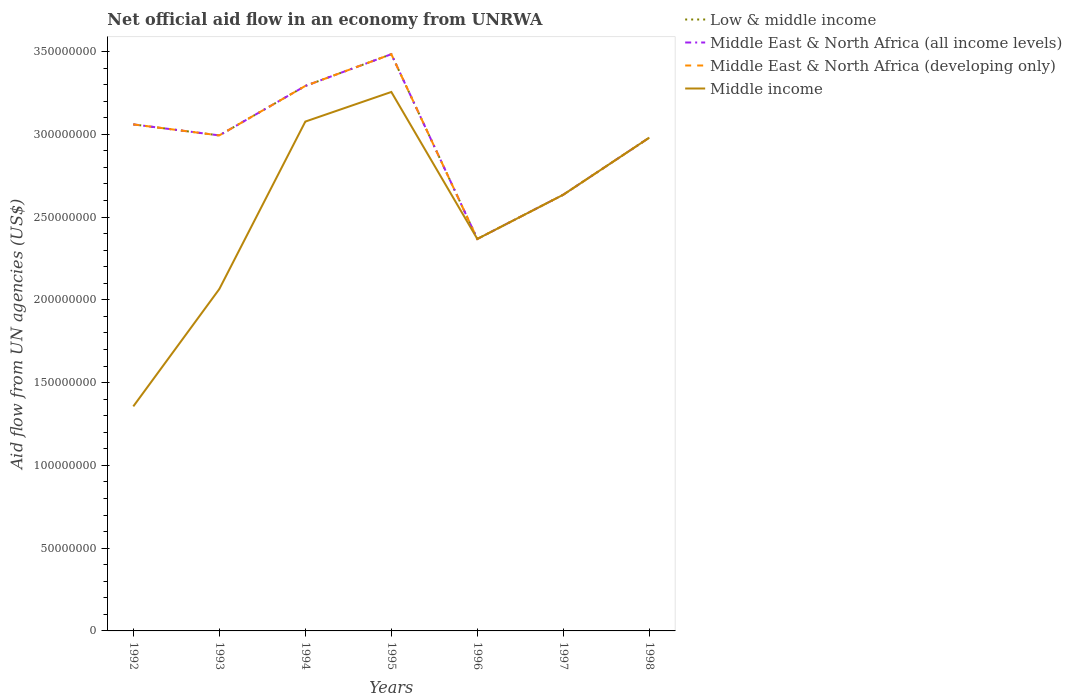How many different coloured lines are there?
Make the answer very short. 4. Is the number of lines equal to the number of legend labels?
Make the answer very short. Yes. Across all years, what is the maximum net official aid flow in Middle East & North Africa (developing only)?
Offer a very short reply. 2.37e+08. In which year was the net official aid flow in Middle East & North Africa (developing only) maximum?
Make the answer very short. 1996. What is the total net official aid flow in Middle East & North Africa (developing only) in the graph?
Make the answer very short. 1.33e+06. What is the difference between the highest and the second highest net official aid flow in Middle income?
Your answer should be compact. 1.90e+08. Is the net official aid flow in Low & middle income strictly greater than the net official aid flow in Middle East & North Africa (developing only) over the years?
Offer a very short reply. No. What is the difference between two consecutive major ticks on the Y-axis?
Make the answer very short. 5.00e+07. Are the values on the major ticks of Y-axis written in scientific E-notation?
Your answer should be compact. No. Does the graph contain grids?
Your answer should be very brief. No. How are the legend labels stacked?
Provide a short and direct response. Vertical. What is the title of the graph?
Make the answer very short. Net official aid flow in an economy from UNRWA. Does "Bosnia and Herzegovina" appear as one of the legend labels in the graph?
Your answer should be very brief. No. What is the label or title of the Y-axis?
Keep it short and to the point. Aid flow from UN agencies (US$). What is the Aid flow from UN agencies (US$) of Low & middle income in 1992?
Your answer should be compact. 3.06e+08. What is the Aid flow from UN agencies (US$) of Middle East & North Africa (all income levels) in 1992?
Your answer should be very brief. 3.06e+08. What is the Aid flow from UN agencies (US$) in Middle East & North Africa (developing only) in 1992?
Provide a succinct answer. 3.06e+08. What is the Aid flow from UN agencies (US$) of Middle income in 1992?
Give a very brief answer. 1.36e+08. What is the Aid flow from UN agencies (US$) in Low & middle income in 1993?
Your answer should be compact. 2.99e+08. What is the Aid flow from UN agencies (US$) in Middle East & North Africa (all income levels) in 1993?
Offer a terse response. 2.99e+08. What is the Aid flow from UN agencies (US$) in Middle East & North Africa (developing only) in 1993?
Ensure brevity in your answer.  2.99e+08. What is the Aid flow from UN agencies (US$) of Middle income in 1993?
Offer a terse response. 2.07e+08. What is the Aid flow from UN agencies (US$) of Low & middle income in 1994?
Your answer should be compact. 3.29e+08. What is the Aid flow from UN agencies (US$) in Middle East & North Africa (all income levels) in 1994?
Offer a terse response. 3.29e+08. What is the Aid flow from UN agencies (US$) in Middle East & North Africa (developing only) in 1994?
Make the answer very short. 3.29e+08. What is the Aid flow from UN agencies (US$) in Middle income in 1994?
Ensure brevity in your answer.  3.08e+08. What is the Aid flow from UN agencies (US$) of Low & middle income in 1995?
Provide a short and direct response. 3.48e+08. What is the Aid flow from UN agencies (US$) of Middle East & North Africa (all income levels) in 1995?
Offer a very short reply. 3.48e+08. What is the Aid flow from UN agencies (US$) of Middle East & North Africa (developing only) in 1995?
Offer a terse response. 3.48e+08. What is the Aid flow from UN agencies (US$) in Middle income in 1995?
Offer a terse response. 3.26e+08. What is the Aid flow from UN agencies (US$) of Low & middle income in 1996?
Your response must be concise. 2.37e+08. What is the Aid flow from UN agencies (US$) of Middle East & North Africa (all income levels) in 1996?
Keep it short and to the point. 2.37e+08. What is the Aid flow from UN agencies (US$) of Middle East & North Africa (developing only) in 1996?
Offer a very short reply. 2.37e+08. What is the Aid flow from UN agencies (US$) in Middle income in 1996?
Your answer should be very brief. 2.37e+08. What is the Aid flow from UN agencies (US$) of Low & middle income in 1997?
Your response must be concise. 2.64e+08. What is the Aid flow from UN agencies (US$) of Middle East & North Africa (all income levels) in 1997?
Offer a very short reply. 2.64e+08. What is the Aid flow from UN agencies (US$) in Middle East & North Africa (developing only) in 1997?
Ensure brevity in your answer.  2.64e+08. What is the Aid flow from UN agencies (US$) of Middle income in 1997?
Ensure brevity in your answer.  2.64e+08. What is the Aid flow from UN agencies (US$) in Low & middle income in 1998?
Your answer should be compact. 2.98e+08. What is the Aid flow from UN agencies (US$) in Middle East & North Africa (all income levels) in 1998?
Make the answer very short. 2.98e+08. What is the Aid flow from UN agencies (US$) of Middle East & North Africa (developing only) in 1998?
Give a very brief answer. 2.98e+08. What is the Aid flow from UN agencies (US$) in Middle income in 1998?
Your answer should be very brief. 2.98e+08. Across all years, what is the maximum Aid flow from UN agencies (US$) of Low & middle income?
Offer a very short reply. 3.48e+08. Across all years, what is the maximum Aid flow from UN agencies (US$) of Middle East & North Africa (all income levels)?
Provide a succinct answer. 3.48e+08. Across all years, what is the maximum Aid flow from UN agencies (US$) of Middle East & North Africa (developing only)?
Keep it short and to the point. 3.48e+08. Across all years, what is the maximum Aid flow from UN agencies (US$) in Middle income?
Offer a terse response. 3.26e+08. Across all years, what is the minimum Aid flow from UN agencies (US$) of Low & middle income?
Keep it short and to the point. 2.37e+08. Across all years, what is the minimum Aid flow from UN agencies (US$) in Middle East & North Africa (all income levels)?
Keep it short and to the point. 2.37e+08. Across all years, what is the minimum Aid flow from UN agencies (US$) of Middle East & North Africa (developing only)?
Your response must be concise. 2.37e+08. Across all years, what is the minimum Aid flow from UN agencies (US$) of Middle income?
Make the answer very short. 1.36e+08. What is the total Aid flow from UN agencies (US$) of Low & middle income in the graph?
Offer a very short reply. 2.08e+09. What is the total Aid flow from UN agencies (US$) in Middle East & North Africa (all income levels) in the graph?
Give a very brief answer. 2.08e+09. What is the total Aid flow from UN agencies (US$) in Middle East & North Africa (developing only) in the graph?
Keep it short and to the point. 2.08e+09. What is the total Aid flow from UN agencies (US$) in Middle income in the graph?
Provide a short and direct response. 1.77e+09. What is the difference between the Aid flow from UN agencies (US$) of Low & middle income in 1992 and that in 1993?
Provide a short and direct response. 6.65e+06. What is the difference between the Aid flow from UN agencies (US$) in Middle East & North Africa (all income levels) in 1992 and that in 1993?
Your response must be concise. 6.65e+06. What is the difference between the Aid flow from UN agencies (US$) in Middle East & North Africa (developing only) in 1992 and that in 1993?
Your answer should be very brief. 6.65e+06. What is the difference between the Aid flow from UN agencies (US$) of Middle income in 1992 and that in 1993?
Ensure brevity in your answer.  -7.09e+07. What is the difference between the Aid flow from UN agencies (US$) in Low & middle income in 1992 and that in 1994?
Make the answer very short. -2.32e+07. What is the difference between the Aid flow from UN agencies (US$) of Middle East & North Africa (all income levels) in 1992 and that in 1994?
Make the answer very short. -2.32e+07. What is the difference between the Aid flow from UN agencies (US$) of Middle East & North Africa (developing only) in 1992 and that in 1994?
Offer a terse response. -2.32e+07. What is the difference between the Aid flow from UN agencies (US$) in Middle income in 1992 and that in 1994?
Offer a very short reply. -1.72e+08. What is the difference between the Aid flow from UN agencies (US$) of Low & middle income in 1992 and that in 1995?
Make the answer very short. -4.24e+07. What is the difference between the Aid flow from UN agencies (US$) in Middle East & North Africa (all income levels) in 1992 and that in 1995?
Ensure brevity in your answer.  -4.24e+07. What is the difference between the Aid flow from UN agencies (US$) of Middle East & North Africa (developing only) in 1992 and that in 1995?
Offer a terse response. -4.24e+07. What is the difference between the Aid flow from UN agencies (US$) of Middle income in 1992 and that in 1995?
Provide a short and direct response. -1.90e+08. What is the difference between the Aid flow from UN agencies (US$) in Low & middle income in 1992 and that in 1996?
Ensure brevity in your answer.  6.92e+07. What is the difference between the Aid flow from UN agencies (US$) in Middle East & North Africa (all income levels) in 1992 and that in 1996?
Your response must be concise. 6.92e+07. What is the difference between the Aid flow from UN agencies (US$) of Middle East & North Africa (developing only) in 1992 and that in 1996?
Give a very brief answer. 6.92e+07. What is the difference between the Aid flow from UN agencies (US$) of Middle income in 1992 and that in 1996?
Ensure brevity in your answer.  -1.01e+08. What is the difference between the Aid flow from UN agencies (US$) in Low & middle income in 1992 and that in 1997?
Offer a very short reply. 4.25e+07. What is the difference between the Aid flow from UN agencies (US$) of Middle East & North Africa (all income levels) in 1992 and that in 1997?
Your answer should be very brief. 4.25e+07. What is the difference between the Aid flow from UN agencies (US$) in Middle East & North Africa (developing only) in 1992 and that in 1997?
Ensure brevity in your answer.  4.25e+07. What is the difference between the Aid flow from UN agencies (US$) in Middle income in 1992 and that in 1997?
Your answer should be very brief. -1.28e+08. What is the difference between the Aid flow from UN agencies (US$) in Low & middle income in 1992 and that in 1998?
Provide a succinct answer. 7.98e+06. What is the difference between the Aid flow from UN agencies (US$) in Middle East & North Africa (all income levels) in 1992 and that in 1998?
Keep it short and to the point. 7.98e+06. What is the difference between the Aid flow from UN agencies (US$) in Middle East & North Africa (developing only) in 1992 and that in 1998?
Ensure brevity in your answer.  7.98e+06. What is the difference between the Aid flow from UN agencies (US$) of Middle income in 1992 and that in 1998?
Your response must be concise. -1.62e+08. What is the difference between the Aid flow from UN agencies (US$) in Low & middle income in 1993 and that in 1994?
Keep it short and to the point. -2.99e+07. What is the difference between the Aid flow from UN agencies (US$) in Middle East & North Africa (all income levels) in 1993 and that in 1994?
Make the answer very short. -2.99e+07. What is the difference between the Aid flow from UN agencies (US$) in Middle East & North Africa (developing only) in 1993 and that in 1994?
Provide a short and direct response. -2.99e+07. What is the difference between the Aid flow from UN agencies (US$) in Middle income in 1993 and that in 1994?
Provide a succinct answer. -1.01e+08. What is the difference between the Aid flow from UN agencies (US$) in Low & middle income in 1993 and that in 1995?
Offer a terse response. -4.91e+07. What is the difference between the Aid flow from UN agencies (US$) in Middle East & North Africa (all income levels) in 1993 and that in 1995?
Keep it short and to the point. -4.91e+07. What is the difference between the Aid flow from UN agencies (US$) of Middle East & North Africa (developing only) in 1993 and that in 1995?
Make the answer very short. -4.91e+07. What is the difference between the Aid flow from UN agencies (US$) in Middle income in 1993 and that in 1995?
Make the answer very short. -1.19e+08. What is the difference between the Aid flow from UN agencies (US$) in Low & middle income in 1993 and that in 1996?
Ensure brevity in your answer.  6.26e+07. What is the difference between the Aid flow from UN agencies (US$) in Middle East & North Africa (all income levels) in 1993 and that in 1996?
Make the answer very short. 6.26e+07. What is the difference between the Aid flow from UN agencies (US$) of Middle East & North Africa (developing only) in 1993 and that in 1996?
Your answer should be very brief. 6.26e+07. What is the difference between the Aid flow from UN agencies (US$) of Middle income in 1993 and that in 1996?
Your response must be concise. -3.03e+07. What is the difference between the Aid flow from UN agencies (US$) of Low & middle income in 1993 and that in 1997?
Offer a very short reply. 3.58e+07. What is the difference between the Aid flow from UN agencies (US$) in Middle East & North Africa (all income levels) in 1993 and that in 1997?
Provide a succinct answer. 3.58e+07. What is the difference between the Aid flow from UN agencies (US$) in Middle East & North Africa (developing only) in 1993 and that in 1997?
Your answer should be compact. 3.58e+07. What is the difference between the Aid flow from UN agencies (US$) in Middle income in 1993 and that in 1997?
Offer a terse response. -5.70e+07. What is the difference between the Aid flow from UN agencies (US$) in Low & middle income in 1993 and that in 1998?
Your answer should be compact. 1.33e+06. What is the difference between the Aid flow from UN agencies (US$) in Middle East & North Africa (all income levels) in 1993 and that in 1998?
Your answer should be very brief. 1.33e+06. What is the difference between the Aid flow from UN agencies (US$) in Middle East & North Africa (developing only) in 1993 and that in 1998?
Offer a very short reply. 1.33e+06. What is the difference between the Aid flow from UN agencies (US$) of Middle income in 1993 and that in 1998?
Keep it short and to the point. -9.15e+07. What is the difference between the Aid flow from UN agencies (US$) in Low & middle income in 1994 and that in 1995?
Offer a terse response. -1.92e+07. What is the difference between the Aid flow from UN agencies (US$) in Middle East & North Africa (all income levels) in 1994 and that in 1995?
Make the answer very short. -1.92e+07. What is the difference between the Aid flow from UN agencies (US$) in Middle East & North Africa (developing only) in 1994 and that in 1995?
Ensure brevity in your answer.  -1.92e+07. What is the difference between the Aid flow from UN agencies (US$) of Middle income in 1994 and that in 1995?
Your answer should be compact. -1.79e+07. What is the difference between the Aid flow from UN agencies (US$) of Low & middle income in 1994 and that in 1996?
Offer a terse response. 9.24e+07. What is the difference between the Aid flow from UN agencies (US$) in Middle East & North Africa (all income levels) in 1994 and that in 1996?
Keep it short and to the point. 9.24e+07. What is the difference between the Aid flow from UN agencies (US$) of Middle East & North Africa (developing only) in 1994 and that in 1996?
Provide a succinct answer. 9.24e+07. What is the difference between the Aid flow from UN agencies (US$) in Middle income in 1994 and that in 1996?
Provide a succinct answer. 7.09e+07. What is the difference between the Aid flow from UN agencies (US$) in Low & middle income in 1994 and that in 1997?
Provide a short and direct response. 6.57e+07. What is the difference between the Aid flow from UN agencies (US$) of Middle East & North Africa (all income levels) in 1994 and that in 1997?
Provide a succinct answer. 6.57e+07. What is the difference between the Aid flow from UN agencies (US$) of Middle East & North Africa (developing only) in 1994 and that in 1997?
Provide a short and direct response. 6.57e+07. What is the difference between the Aid flow from UN agencies (US$) of Middle income in 1994 and that in 1997?
Your answer should be compact. 4.42e+07. What is the difference between the Aid flow from UN agencies (US$) of Low & middle income in 1994 and that in 1998?
Offer a terse response. 3.12e+07. What is the difference between the Aid flow from UN agencies (US$) of Middle East & North Africa (all income levels) in 1994 and that in 1998?
Your answer should be compact. 3.12e+07. What is the difference between the Aid flow from UN agencies (US$) in Middle East & North Africa (developing only) in 1994 and that in 1998?
Provide a succinct answer. 3.12e+07. What is the difference between the Aid flow from UN agencies (US$) of Middle income in 1994 and that in 1998?
Offer a terse response. 9.68e+06. What is the difference between the Aid flow from UN agencies (US$) in Low & middle income in 1995 and that in 1996?
Provide a short and direct response. 1.12e+08. What is the difference between the Aid flow from UN agencies (US$) of Middle East & North Africa (all income levels) in 1995 and that in 1996?
Give a very brief answer. 1.12e+08. What is the difference between the Aid flow from UN agencies (US$) of Middle East & North Africa (developing only) in 1995 and that in 1996?
Provide a short and direct response. 1.12e+08. What is the difference between the Aid flow from UN agencies (US$) in Middle income in 1995 and that in 1996?
Ensure brevity in your answer.  8.88e+07. What is the difference between the Aid flow from UN agencies (US$) in Low & middle income in 1995 and that in 1997?
Provide a short and direct response. 8.49e+07. What is the difference between the Aid flow from UN agencies (US$) in Middle East & North Africa (all income levels) in 1995 and that in 1997?
Provide a succinct answer. 8.49e+07. What is the difference between the Aid flow from UN agencies (US$) in Middle East & North Africa (developing only) in 1995 and that in 1997?
Ensure brevity in your answer.  8.49e+07. What is the difference between the Aid flow from UN agencies (US$) of Middle income in 1995 and that in 1997?
Your response must be concise. 6.20e+07. What is the difference between the Aid flow from UN agencies (US$) of Low & middle income in 1995 and that in 1998?
Your answer should be very brief. 5.04e+07. What is the difference between the Aid flow from UN agencies (US$) in Middle East & North Africa (all income levels) in 1995 and that in 1998?
Keep it short and to the point. 5.04e+07. What is the difference between the Aid flow from UN agencies (US$) in Middle East & North Africa (developing only) in 1995 and that in 1998?
Provide a succinct answer. 5.04e+07. What is the difference between the Aid flow from UN agencies (US$) in Middle income in 1995 and that in 1998?
Your answer should be compact. 2.76e+07. What is the difference between the Aid flow from UN agencies (US$) in Low & middle income in 1996 and that in 1997?
Ensure brevity in your answer.  -2.67e+07. What is the difference between the Aid flow from UN agencies (US$) of Middle East & North Africa (all income levels) in 1996 and that in 1997?
Keep it short and to the point. -2.67e+07. What is the difference between the Aid flow from UN agencies (US$) in Middle East & North Africa (developing only) in 1996 and that in 1997?
Your response must be concise. -2.67e+07. What is the difference between the Aid flow from UN agencies (US$) in Middle income in 1996 and that in 1997?
Offer a very short reply. -2.67e+07. What is the difference between the Aid flow from UN agencies (US$) in Low & middle income in 1996 and that in 1998?
Provide a short and direct response. -6.12e+07. What is the difference between the Aid flow from UN agencies (US$) in Middle East & North Africa (all income levels) in 1996 and that in 1998?
Your response must be concise. -6.12e+07. What is the difference between the Aid flow from UN agencies (US$) in Middle East & North Africa (developing only) in 1996 and that in 1998?
Offer a very short reply. -6.12e+07. What is the difference between the Aid flow from UN agencies (US$) in Middle income in 1996 and that in 1998?
Offer a very short reply. -6.12e+07. What is the difference between the Aid flow from UN agencies (US$) of Low & middle income in 1997 and that in 1998?
Offer a very short reply. -3.45e+07. What is the difference between the Aid flow from UN agencies (US$) of Middle East & North Africa (all income levels) in 1997 and that in 1998?
Offer a very short reply. -3.45e+07. What is the difference between the Aid flow from UN agencies (US$) in Middle East & North Africa (developing only) in 1997 and that in 1998?
Your answer should be compact. -3.45e+07. What is the difference between the Aid flow from UN agencies (US$) in Middle income in 1997 and that in 1998?
Offer a very short reply. -3.45e+07. What is the difference between the Aid flow from UN agencies (US$) in Low & middle income in 1992 and the Aid flow from UN agencies (US$) in Middle East & North Africa (all income levels) in 1993?
Your response must be concise. 6.65e+06. What is the difference between the Aid flow from UN agencies (US$) of Low & middle income in 1992 and the Aid flow from UN agencies (US$) of Middle East & North Africa (developing only) in 1993?
Your answer should be compact. 6.65e+06. What is the difference between the Aid flow from UN agencies (US$) in Low & middle income in 1992 and the Aid flow from UN agencies (US$) in Middle income in 1993?
Your response must be concise. 9.95e+07. What is the difference between the Aid flow from UN agencies (US$) in Middle East & North Africa (all income levels) in 1992 and the Aid flow from UN agencies (US$) in Middle East & North Africa (developing only) in 1993?
Your answer should be compact. 6.65e+06. What is the difference between the Aid flow from UN agencies (US$) of Middle East & North Africa (all income levels) in 1992 and the Aid flow from UN agencies (US$) of Middle income in 1993?
Make the answer very short. 9.95e+07. What is the difference between the Aid flow from UN agencies (US$) of Middle East & North Africa (developing only) in 1992 and the Aid flow from UN agencies (US$) of Middle income in 1993?
Provide a short and direct response. 9.95e+07. What is the difference between the Aid flow from UN agencies (US$) of Low & middle income in 1992 and the Aid flow from UN agencies (US$) of Middle East & North Africa (all income levels) in 1994?
Give a very brief answer. -2.32e+07. What is the difference between the Aid flow from UN agencies (US$) in Low & middle income in 1992 and the Aid flow from UN agencies (US$) in Middle East & North Africa (developing only) in 1994?
Your answer should be compact. -2.32e+07. What is the difference between the Aid flow from UN agencies (US$) in Low & middle income in 1992 and the Aid flow from UN agencies (US$) in Middle income in 1994?
Offer a very short reply. -1.70e+06. What is the difference between the Aid flow from UN agencies (US$) in Middle East & North Africa (all income levels) in 1992 and the Aid flow from UN agencies (US$) in Middle East & North Africa (developing only) in 1994?
Provide a succinct answer. -2.32e+07. What is the difference between the Aid flow from UN agencies (US$) in Middle East & North Africa (all income levels) in 1992 and the Aid flow from UN agencies (US$) in Middle income in 1994?
Give a very brief answer. -1.70e+06. What is the difference between the Aid flow from UN agencies (US$) of Middle East & North Africa (developing only) in 1992 and the Aid flow from UN agencies (US$) of Middle income in 1994?
Your answer should be very brief. -1.70e+06. What is the difference between the Aid flow from UN agencies (US$) in Low & middle income in 1992 and the Aid flow from UN agencies (US$) in Middle East & North Africa (all income levels) in 1995?
Your answer should be very brief. -4.24e+07. What is the difference between the Aid flow from UN agencies (US$) in Low & middle income in 1992 and the Aid flow from UN agencies (US$) in Middle East & North Africa (developing only) in 1995?
Keep it short and to the point. -4.24e+07. What is the difference between the Aid flow from UN agencies (US$) of Low & middle income in 1992 and the Aid flow from UN agencies (US$) of Middle income in 1995?
Provide a short and direct response. -1.96e+07. What is the difference between the Aid flow from UN agencies (US$) of Middle East & North Africa (all income levels) in 1992 and the Aid flow from UN agencies (US$) of Middle East & North Africa (developing only) in 1995?
Offer a very short reply. -4.24e+07. What is the difference between the Aid flow from UN agencies (US$) in Middle East & North Africa (all income levels) in 1992 and the Aid flow from UN agencies (US$) in Middle income in 1995?
Keep it short and to the point. -1.96e+07. What is the difference between the Aid flow from UN agencies (US$) in Middle East & North Africa (developing only) in 1992 and the Aid flow from UN agencies (US$) in Middle income in 1995?
Your response must be concise. -1.96e+07. What is the difference between the Aid flow from UN agencies (US$) of Low & middle income in 1992 and the Aid flow from UN agencies (US$) of Middle East & North Africa (all income levels) in 1996?
Ensure brevity in your answer.  6.92e+07. What is the difference between the Aid flow from UN agencies (US$) in Low & middle income in 1992 and the Aid flow from UN agencies (US$) in Middle East & North Africa (developing only) in 1996?
Offer a very short reply. 6.92e+07. What is the difference between the Aid flow from UN agencies (US$) in Low & middle income in 1992 and the Aid flow from UN agencies (US$) in Middle income in 1996?
Provide a short and direct response. 6.92e+07. What is the difference between the Aid flow from UN agencies (US$) in Middle East & North Africa (all income levels) in 1992 and the Aid flow from UN agencies (US$) in Middle East & North Africa (developing only) in 1996?
Offer a terse response. 6.92e+07. What is the difference between the Aid flow from UN agencies (US$) of Middle East & North Africa (all income levels) in 1992 and the Aid flow from UN agencies (US$) of Middle income in 1996?
Your answer should be compact. 6.92e+07. What is the difference between the Aid flow from UN agencies (US$) in Middle East & North Africa (developing only) in 1992 and the Aid flow from UN agencies (US$) in Middle income in 1996?
Offer a terse response. 6.92e+07. What is the difference between the Aid flow from UN agencies (US$) of Low & middle income in 1992 and the Aid flow from UN agencies (US$) of Middle East & North Africa (all income levels) in 1997?
Offer a very short reply. 4.25e+07. What is the difference between the Aid flow from UN agencies (US$) of Low & middle income in 1992 and the Aid flow from UN agencies (US$) of Middle East & North Africa (developing only) in 1997?
Offer a very short reply. 4.25e+07. What is the difference between the Aid flow from UN agencies (US$) in Low & middle income in 1992 and the Aid flow from UN agencies (US$) in Middle income in 1997?
Offer a terse response. 4.25e+07. What is the difference between the Aid flow from UN agencies (US$) in Middle East & North Africa (all income levels) in 1992 and the Aid flow from UN agencies (US$) in Middle East & North Africa (developing only) in 1997?
Give a very brief answer. 4.25e+07. What is the difference between the Aid flow from UN agencies (US$) in Middle East & North Africa (all income levels) in 1992 and the Aid flow from UN agencies (US$) in Middle income in 1997?
Provide a succinct answer. 4.25e+07. What is the difference between the Aid flow from UN agencies (US$) in Middle East & North Africa (developing only) in 1992 and the Aid flow from UN agencies (US$) in Middle income in 1997?
Offer a very short reply. 4.25e+07. What is the difference between the Aid flow from UN agencies (US$) in Low & middle income in 1992 and the Aid flow from UN agencies (US$) in Middle East & North Africa (all income levels) in 1998?
Provide a short and direct response. 7.98e+06. What is the difference between the Aid flow from UN agencies (US$) of Low & middle income in 1992 and the Aid flow from UN agencies (US$) of Middle East & North Africa (developing only) in 1998?
Your answer should be very brief. 7.98e+06. What is the difference between the Aid flow from UN agencies (US$) in Low & middle income in 1992 and the Aid flow from UN agencies (US$) in Middle income in 1998?
Provide a short and direct response. 7.98e+06. What is the difference between the Aid flow from UN agencies (US$) of Middle East & North Africa (all income levels) in 1992 and the Aid flow from UN agencies (US$) of Middle East & North Africa (developing only) in 1998?
Your answer should be very brief. 7.98e+06. What is the difference between the Aid flow from UN agencies (US$) in Middle East & North Africa (all income levels) in 1992 and the Aid flow from UN agencies (US$) in Middle income in 1998?
Ensure brevity in your answer.  7.98e+06. What is the difference between the Aid flow from UN agencies (US$) in Middle East & North Africa (developing only) in 1992 and the Aid flow from UN agencies (US$) in Middle income in 1998?
Keep it short and to the point. 7.98e+06. What is the difference between the Aid flow from UN agencies (US$) in Low & middle income in 1993 and the Aid flow from UN agencies (US$) in Middle East & North Africa (all income levels) in 1994?
Make the answer very short. -2.99e+07. What is the difference between the Aid flow from UN agencies (US$) of Low & middle income in 1993 and the Aid flow from UN agencies (US$) of Middle East & North Africa (developing only) in 1994?
Keep it short and to the point. -2.99e+07. What is the difference between the Aid flow from UN agencies (US$) in Low & middle income in 1993 and the Aid flow from UN agencies (US$) in Middle income in 1994?
Give a very brief answer. -8.35e+06. What is the difference between the Aid flow from UN agencies (US$) of Middle East & North Africa (all income levels) in 1993 and the Aid flow from UN agencies (US$) of Middle East & North Africa (developing only) in 1994?
Your answer should be very brief. -2.99e+07. What is the difference between the Aid flow from UN agencies (US$) in Middle East & North Africa (all income levels) in 1993 and the Aid flow from UN agencies (US$) in Middle income in 1994?
Your response must be concise. -8.35e+06. What is the difference between the Aid flow from UN agencies (US$) of Middle East & North Africa (developing only) in 1993 and the Aid flow from UN agencies (US$) of Middle income in 1994?
Keep it short and to the point. -8.35e+06. What is the difference between the Aid flow from UN agencies (US$) in Low & middle income in 1993 and the Aid flow from UN agencies (US$) in Middle East & North Africa (all income levels) in 1995?
Keep it short and to the point. -4.91e+07. What is the difference between the Aid flow from UN agencies (US$) in Low & middle income in 1993 and the Aid flow from UN agencies (US$) in Middle East & North Africa (developing only) in 1995?
Provide a succinct answer. -4.91e+07. What is the difference between the Aid flow from UN agencies (US$) of Low & middle income in 1993 and the Aid flow from UN agencies (US$) of Middle income in 1995?
Your answer should be very brief. -2.62e+07. What is the difference between the Aid flow from UN agencies (US$) of Middle East & North Africa (all income levels) in 1993 and the Aid flow from UN agencies (US$) of Middle East & North Africa (developing only) in 1995?
Provide a short and direct response. -4.91e+07. What is the difference between the Aid flow from UN agencies (US$) of Middle East & North Africa (all income levels) in 1993 and the Aid flow from UN agencies (US$) of Middle income in 1995?
Offer a very short reply. -2.62e+07. What is the difference between the Aid flow from UN agencies (US$) of Middle East & North Africa (developing only) in 1993 and the Aid flow from UN agencies (US$) of Middle income in 1995?
Offer a terse response. -2.62e+07. What is the difference between the Aid flow from UN agencies (US$) in Low & middle income in 1993 and the Aid flow from UN agencies (US$) in Middle East & North Africa (all income levels) in 1996?
Your response must be concise. 6.26e+07. What is the difference between the Aid flow from UN agencies (US$) of Low & middle income in 1993 and the Aid flow from UN agencies (US$) of Middle East & North Africa (developing only) in 1996?
Your response must be concise. 6.26e+07. What is the difference between the Aid flow from UN agencies (US$) of Low & middle income in 1993 and the Aid flow from UN agencies (US$) of Middle income in 1996?
Offer a terse response. 6.26e+07. What is the difference between the Aid flow from UN agencies (US$) in Middle East & North Africa (all income levels) in 1993 and the Aid flow from UN agencies (US$) in Middle East & North Africa (developing only) in 1996?
Offer a very short reply. 6.26e+07. What is the difference between the Aid flow from UN agencies (US$) of Middle East & North Africa (all income levels) in 1993 and the Aid flow from UN agencies (US$) of Middle income in 1996?
Your answer should be very brief. 6.26e+07. What is the difference between the Aid flow from UN agencies (US$) of Middle East & North Africa (developing only) in 1993 and the Aid flow from UN agencies (US$) of Middle income in 1996?
Your answer should be very brief. 6.26e+07. What is the difference between the Aid flow from UN agencies (US$) in Low & middle income in 1993 and the Aid flow from UN agencies (US$) in Middle East & North Africa (all income levels) in 1997?
Your response must be concise. 3.58e+07. What is the difference between the Aid flow from UN agencies (US$) of Low & middle income in 1993 and the Aid flow from UN agencies (US$) of Middle East & North Africa (developing only) in 1997?
Ensure brevity in your answer.  3.58e+07. What is the difference between the Aid flow from UN agencies (US$) in Low & middle income in 1993 and the Aid flow from UN agencies (US$) in Middle income in 1997?
Offer a terse response. 3.58e+07. What is the difference between the Aid flow from UN agencies (US$) in Middle East & North Africa (all income levels) in 1993 and the Aid flow from UN agencies (US$) in Middle East & North Africa (developing only) in 1997?
Ensure brevity in your answer.  3.58e+07. What is the difference between the Aid flow from UN agencies (US$) in Middle East & North Africa (all income levels) in 1993 and the Aid flow from UN agencies (US$) in Middle income in 1997?
Offer a very short reply. 3.58e+07. What is the difference between the Aid flow from UN agencies (US$) of Middle East & North Africa (developing only) in 1993 and the Aid flow from UN agencies (US$) of Middle income in 1997?
Keep it short and to the point. 3.58e+07. What is the difference between the Aid flow from UN agencies (US$) in Low & middle income in 1993 and the Aid flow from UN agencies (US$) in Middle East & North Africa (all income levels) in 1998?
Your answer should be compact. 1.33e+06. What is the difference between the Aid flow from UN agencies (US$) in Low & middle income in 1993 and the Aid flow from UN agencies (US$) in Middle East & North Africa (developing only) in 1998?
Provide a short and direct response. 1.33e+06. What is the difference between the Aid flow from UN agencies (US$) in Low & middle income in 1993 and the Aid flow from UN agencies (US$) in Middle income in 1998?
Your answer should be compact. 1.33e+06. What is the difference between the Aid flow from UN agencies (US$) of Middle East & North Africa (all income levels) in 1993 and the Aid flow from UN agencies (US$) of Middle East & North Africa (developing only) in 1998?
Your answer should be very brief. 1.33e+06. What is the difference between the Aid flow from UN agencies (US$) of Middle East & North Africa (all income levels) in 1993 and the Aid flow from UN agencies (US$) of Middle income in 1998?
Provide a succinct answer. 1.33e+06. What is the difference between the Aid flow from UN agencies (US$) of Middle East & North Africa (developing only) in 1993 and the Aid flow from UN agencies (US$) of Middle income in 1998?
Your answer should be very brief. 1.33e+06. What is the difference between the Aid flow from UN agencies (US$) in Low & middle income in 1994 and the Aid flow from UN agencies (US$) in Middle East & North Africa (all income levels) in 1995?
Keep it short and to the point. -1.92e+07. What is the difference between the Aid flow from UN agencies (US$) in Low & middle income in 1994 and the Aid flow from UN agencies (US$) in Middle East & North Africa (developing only) in 1995?
Give a very brief answer. -1.92e+07. What is the difference between the Aid flow from UN agencies (US$) in Low & middle income in 1994 and the Aid flow from UN agencies (US$) in Middle income in 1995?
Give a very brief answer. 3.64e+06. What is the difference between the Aid flow from UN agencies (US$) of Middle East & North Africa (all income levels) in 1994 and the Aid flow from UN agencies (US$) of Middle East & North Africa (developing only) in 1995?
Offer a terse response. -1.92e+07. What is the difference between the Aid flow from UN agencies (US$) in Middle East & North Africa (all income levels) in 1994 and the Aid flow from UN agencies (US$) in Middle income in 1995?
Your answer should be compact. 3.64e+06. What is the difference between the Aid flow from UN agencies (US$) in Middle East & North Africa (developing only) in 1994 and the Aid flow from UN agencies (US$) in Middle income in 1995?
Your response must be concise. 3.64e+06. What is the difference between the Aid flow from UN agencies (US$) in Low & middle income in 1994 and the Aid flow from UN agencies (US$) in Middle East & North Africa (all income levels) in 1996?
Provide a succinct answer. 9.24e+07. What is the difference between the Aid flow from UN agencies (US$) in Low & middle income in 1994 and the Aid flow from UN agencies (US$) in Middle East & North Africa (developing only) in 1996?
Give a very brief answer. 9.24e+07. What is the difference between the Aid flow from UN agencies (US$) of Low & middle income in 1994 and the Aid flow from UN agencies (US$) of Middle income in 1996?
Your answer should be very brief. 9.24e+07. What is the difference between the Aid flow from UN agencies (US$) of Middle East & North Africa (all income levels) in 1994 and the Aid flow from UN agencies (US$) of Middle East & North Africa (developing only) in 1996?
Your response must be concise. 9.24e+07. What is the difference between the Aid flow from UN agencies (US$) in Middle East & North Africa (all income levels) in 1994 and the Aid flow from UN agencies (US$) in Middle income in 1996?
Ensure brevity in your answer.  9.24e+07. What is the difference between the Aid flow from UN agencies (US$) in Middle East & North Africa (developing only) in 1994 and the Aid flow from UN agencies (US$) in Middle income in 1996?
Keep it short and to the point. 9.24e+07. What is the difference between the Aid flow from UN agencies (US$) in Low & middle income in 1994 and the Aid flow from UN agencies (US$) in Middle East & North Africa (all income levels) in 1997?
Offer a terse response. 6.57e+07. What is the difference between the Aid flow from UN agencies (US$) in Low & middle income in 1994 and the Aid flow from UN agencies (US$) in Middle East & North Africa (developing only) in 1997?
Your response must be concise. 6.57e+07. What is the difference between the Aid flow from UN agencies (US$) of Low & middle income in 1994 and the Aid flow from UN agencies (US$) of Middle income in 1997?
Make the answer very short. 6.57e+07. What is the difference between the Aid flow from UN agencies (US$) in Middle East & North Africa (all income levels) in 1994 and the Aid flow from UN agencies (US$) in Middle East & North Africa (developing only) in 1997?
Ensure brevity in your answer.  6.57e+07. What is the difference between the Aid flow from UN agencies (US$) in Middle East & North Africa (all income levels) in 1994 and the Aid flow from UN agencies (US$) in Middle income in 1997?
Provide a succinct answer. 6.57e+07. What is the difference between the Aid flow from UN agencies (US$) of Middle East & North Africa (developing only) in 1994 and the Aid flow from UN agencies (US$) of Middle income in 1997?
Offer a very short reply. 6.57e+07. What is the difference between the Aid flow from UN agencies (US$) of Low & middle income in 1994 and the Aid flow from UN agencies (US$) of Middle East & North Africa (all income levels) in 1998?
Provide a short and direct response. 3.12e+07. What is the difference between the Aid flow from UN agencies (US$) of Low & middle income in 1994 and the Aid flow from UN agencies (US$) of Middle East & North Africa (developing only) in 1998?
Give a very brief answer. 3.12e+07. What is the difference between the Aid flow from UN agencies (US$) of Low & middle income in 1994 and the Aid flow from UN agencies (US$) of Middle income in 1998?
Provide a succinct answer. 3.12e+07. What is the difference between the Aid flow from UN agencies (US$) in Middle East & North Africa (all income levels) in 1994 and the Aid flow from UN agencies (US$) in Middle East & North Africa (developing only) in 1998?
Your answer should be very brief. 3.12e+07. What is the difference between the Aid flow from UN agencies (US$) of Middle East & North Africa (all income levels) in 1994 and the Aid flow from UN agencies (US$) of Middle income in 1998?
Provide a short and direct response. 3.12e+07. What is the difference between the Aid flow from UN agencies (US$) in Middle East & North Africa (developing only) in 1994 and the Aid flow from UN agencies (US$) in Middle income in 1998?
Your response must be concise. 3.12e+07. What is the difference between the Aid flow from UN agencies (US$) of Low & middle income in 1995 and the Aid flow from UN agencies (US$) of Middle East & North Africa (all income levels) in 1996?
Your response must be concise. 1.12e+08. What is the difference between the Aid flow from UN agencies (US$) of Low & middle income in 1995 and the Aid flow from UN agencies (US$) of Middle East & North Africa (developing only) in 1996?
Make the answer very short. 1.12e+08. What is the difference between the Aid flow from UN agencies (US$) of Low & middle income in 1995 and the Aid flow from UN agencies (US$) of Middle income in 1996?
Give a very brief answer. 1.12e+08. What is the difference between the Aid flow from UN agencies (US$) of Middle East & North Africa (all income levels) in 1995 and the Aid flow from UN agencies (US$) of Middle East & North Africa (developing only) in 1996?
Ensure brevity in your answer.  1.12e+08. What is the difference between the Aid flow from UN agencies (US$) in Middle East & North Africa (all income levels) in 1995 and the Aid flow from UN agencies (US$) in Middle income in 1996?
Make the answer very short. 1.12e+08. What is the difference between the Aid flow from UN agencies (US$) in Middle East & North Africa (developing only) in 1995 and the Aid flow from UN agencies (US$) in Middle income in 1996?
Your answer should be compact. 1.12e+08. What is the difference between the Aid flow from UN agencies (US$) in Low & middle income in 1995 and the Aid flow from UN agencies (US$) in Middle East & North Africa (all income levels) in 1997?
Your response must be concise. 8.49e+07. What is the difference between the Aid flow from UN agencies (US$) of Low & middle income in 1995 and the Aid flow from UN agencies (US$) of Middle East & North Africa (developing only) in 1997?
Offer a very short reply. 8.49e+07. What is the difference between the Aid flow from UN agencies (US$) of Low & middle income in 1995 and the Aid flow from UN agencies (US$) of Middle income in 1997?
Your answer should be compact. 8.49e+07. What is the difference between the Aid flow from UN agencies (US$) of Middle East & North Africa (all income levels) in 1995 and the Aid flow from UN agencies (US$) of Middle East & North Africa (developing only) in 1997?
Keep it short and to the point. 8.49e+07. What is the difference between the Aid flow from UN agencies (US$) of Middle East & North Africa (all income levels) in 1995 and the Aid flow from UN agencies (US$) of Middle income in 1997?
Offer a terse response. 8.49e+07. What is the difference between the Aid flow from UN agencies (US$) of Middle East & North Africa (developing only) in 1995 and the Aid flow from UN agencies (US$) of Middle income in 1997?
Ensure brevity in your answer.  8.49e+07. What is the difference between the Aid flow from UN agencies (US$) in Low & middle income in 1995 and the Aid flow from UN agencies (US$) in Middle East & North Africa (all income levels) in 1998?
Your answer should be compact. 5.04e+07. What is the difference between the Aid flow from UN agencies (US$) of Low & middle income in 1995 and the Aid flow from UN agencies (US$) of Middle East & North Africa (developing only) in 1998?
Your answer should be very brief. 5.04e+07. What is the difference between the Aid flow from UN agencies (US$) in Low & middle income in 1995 and the Aid flow from UN agencies (US$) in Middle income in 1998?
Offer a terse response. 5.04e+07. What is the difference between the Aid flow from UN agencies (US$) in Middle East & North Africa (all income levels) in 1995 and the Aid flow from UN agencies (US$) in Middle East & North Africa (developing only) in 1998?
Provide a short and direct response. 5.04e+07. What is the difference between the Aid flow from UN agencies (US$) in Middle East & North Africa (all income levels) in 1995 and the Aid flow from UN agencies (US$) in Middle income in 1998?
Provide a short and direct response. 5.04e+07. What is the difference between the Aid flow from UN agencies (US$) in Middle East & North Africa (developing only) in 1995 and the Aid flow from UN agencies (US$) in Middle income in 1998?
Your answer should be compact. 5.04e+07. What is the difference between the Aid flow from UN agencies (US$) of Low & middle income in 1996 and the Aid flow from UN agencies (US$) of Middle East & North Africa (all income levels) in 1997?
Offer a terse response. -2.67e+07. What is the difference between the Aid flow from UN agencies (US$) in Low & middle income in 1996 and the Aid flow from UN agencies (US$) in Middle East & North Africa (developing only) in 1997?
Offer a terse response. -2.67e+07. What is the difference between the Aid flow from UN agencies (US$) in Low & middle income in 1996 and the Aid flow from UN agencies (US$) in Middle income in 1997?
Provide a succinct answer. -2.67e+07. What is the difference between the Aid flow from UN agencies (US$) of Middle East & North Africa (all income levels) in 1996 and the Aid flow from UN agencies (US$) of Middle East & North Africa (developing only) in 1997?
Your answer should be very brief. -2.67e+07. What is the difference between the Aid flow from UN agencies (US$) of Middle East & North Africa (all income levels) in 1996 and the Aid flow from UN agencies (US$) of Middle income in 1997?
Offer a very short reply. -2.67e+07. What is the difference between the Aid flow from UN agencies (US$) of Middle East & North Africa (developing only) in 1996 and the Aid flow from UN agencies (US$) of Middle income in 1997?
Ensure brevity in your answer.  -2.67e+07. What is the difference between the Aid flow from UN agencies (US$) of Low & middle income in 1996 and the Aid flow from UN agencies (US$) of Middle East & North Africa (all income levels) in 1998?
Provide a succinct answer. -6.12e+07. What is the difference between the Aid flow from UN agencies (US$) in Low & middle income in 1996 and the Aid flow from UN agencies (US$) in Middle East & North Africa (developing only) in 1998?
Your response must be concise. -6.12e+07. What is the difference between the Aid flow from UN agencies (US$) in Low & middle income in 1996 and the Aid flow from UN agencies (US$) in Middle income in 1998?
Provide a succinct answer. -6.12e+07. What is the difference between the Aid flow from UN agencies (US$) in Middle East & North Africa (all income levels) in 1996 and the Aid flow from UN agencies (US$) in Middle East & North Africa (developing only) in 1998?
Provide a succinct answer. -6.12e+07. What is the difference between the Aid flow from UN agencies (US$) of Middle East & North Africa (all income levels) in 1996 and the Aid flow from UN agencies (US$) of Middle income in 1998?
Your answer should be very brief. -6.12e+07. What is the difference between the Aid flow from UN agencies (US$) of Middle East & North Africa (developing only) in 1996 and the Aid flow from UN agencies (US$) of Middle income in 1998?
Give a very brief answer. -6.12e+07. What is the difference between the Aid flow from UN agencies (US$) of Low & middle income in 1997 and the Aid flow from UN agencies (US$) of Middle East & North Africa (all income levels) in 1998?
Offer a terse response. -3.45e+07. What is the difference between the Aid flow from UN agencies (US$) of Low & middle income in 1997 and the Aid flow from UN agencies (US$) of Middle East & North Africa (developing only) in 1998?
Keep it short and to the point. -3.45e+07. What is the difference between the Aid flow from UN agencies (US$) of Low & middle income in 1997 and the Aid flow from UN agencies (US$) of Middle income in 1998?
Keep it short and to the point. -3.45e+07. What is the difference between the Aid flow from UN agencies (US$) of Middle East & North Africa (all income levels) in 1997 and the Aid flow from UN agencies (US$) of Middle East & North Africa (developing only) in 1998?
Provide a succinct answer. -3.45e+07. What is the difference between the Aid flow from UN agencies (US$) in Middle East & North Africa (all income levels) in 1997 and the Aid flow from UN agencies (US$) in Middle income in 1998?
Your answer should be very brief. -3.45e+07. What is the difference between the Aid flow from UN agencies (US$) of Middle East & North Africa (developing only) in 1997 and the Aid flow from UN agencies (US$) of Middle income in 1998?
Your response must be concise. -3.45e+07. What is the average Aid flow from UN agencies (US$) in Low & middle income per year?
Your answer should be very brief. 2.97e+08. What is the average Aid flow from UN agencies (US$) of Middle East & North Africa (all income levels) per year?
Keep it short and to the point. 2.97e+08. What is the average Aid flow from UN agencies (US$) of Middle East & North Africa (developing only) per year?
Your answer should be very brief. 2.97e+08. What is the average Aid flow from UN agencies (US$) in Middle income per year?
Make the answer very short. 2.53e+08. In the year 1992, what is the difference between the Aid flow from UN agencies (US$) of Low & middle income and Aid flow from UN agencies (US$) of Middle East & North Africa (all income levels)?
Provide a short and direct response. 0. In the year 1992, what is the difference between the Aid flow from UN agencies (US$) of Low & middle income and Aid flow from UN agencies (US$) of Middle East & North Africa (developing only)?
Provide a short and direct response. 0. In the year 1992, what is the difference between the Aid flow from UN agencies (US$) of Low & middle income and Aid flow from UN agencies (US$) of Middle income?
Ensure brevity in your answer.  1.70e+08. In the year 1992, what is the difference between the Aid flow from UN agencies (US$) in Middle East & North Africa (all income levels) and Aid flow from UN agencies (US$) in Middle East & North Africa (developing only)?
Keep it short and to the point. 0. In the year 1992, what is the difference between the Aid flow from UN agencies (US$) in Middle East & North Africa (all income levels) and Aid flow from UN agencies (US$) in Middle income?
Make the answer very short. 1.70e+08. In the year 1992, what is the difference between the Aid flow from UN agencies (US$) in Middle East & North Africa (developing only) and Aid flow from UN agencies (US$) in Middle income?
Keep it short and to the point. 1.70e+08. In the year 1993, what is the difference between the Aid flow from UN agencies (US$) in Low & middle income and Aid flow from UN agencies (US$) in Middle income?
Your response must be concise. 9.28e+07. In the year 1993, what is the difference between the Aid flow from UN agencies (US$) in Middle East & North Africa (all income levels) and Aid flow from UN agencies (US$) in Middle income?
Make the answer very short. 9.28e+07. In the year 1993, what is the difference between the Aid flow from UN agencies (US$) in Middle East & North Africa (developing only) and Aid flow from UN agencies (US$) in Middle income?
Make the answer very short. 9.28e+07. In the year 1994, what is the difference between the Aid flow from UN agencies (US$) in Low & middle income and Aid flow from UN agencies (US$) in Middle East & North Africa (developing only)?
Your response must be concise. 0. In the year 1994, what is the difference between the Aid flow from UN agencies (US$) of Low & middle income and Aid flow from UN agencies (US$) of Middle income?
Offer a terse response. 2.15e+07. In the year 1994, what is the difference between the Aid flow from UN agencies (US$) of Middle East & North Africa (all income levels) and Aid flow from UN agencies (US$) of Middle income?
Make the answer very short. 2.15e+07. In the year 1994, what is the difference between the Aid flow from UN agencies (US$) in Middle East & North Africa (developing only) and Aid flow from UN agencies (US$) in Middle income?
Offer a very short reply. 2.15e+07. In the year 1995, what is the difference between the Aid flow from UN agencies (US$) in Low & middle income and Aid flow from UN agencies (US$) in Middle East & North Africa (all income levels)?
Offer a terse response. 0. In the year 1995, what is the difference between the Aid flow from UN agencies (US$) of Low & middle income and Aid flow from UN agencies (US$) of Middle East & North Africa (developing only)?
Your response must be concise. 0. In the year 1995, what is the difference between the Aid flow from UN agencies (US$) of Low & middle income and Aid flow from UN agencies (US$) of Middle income?
Keep it short and to the point. 2.28e+07. In the year 1995, what is the difference between the Aid flow from UN agencies (US$) in Middle East & North Africa (all income levels) and Aid flow from UN agencies (US$) in Middle East & North Africa (developing only)?
Your answer should be compact. 0. In the year 1995, what is the difference between the Aid flow from UN agencies (US$) of Middle East & North Africa (all income levels) and Aid flow from UN agencies (US$) of Middle income?
Offer a terse response. 2.28e+07. In the year 1995, what is the difference between the Aid flow from UN agencies (US$) of Middle East & North Africa (developing only) and Aid flow from UN agencies (US$) of Middle income?
Your response must be concise. 2.28e+07. In the year 1996, what is the difference between the Aid flow from UN agencies (US$) of Low & middle income and Aid flow from UN agencies (US$) of Middle East & North Africa (all income levels)?
Give a very brief answer. 0. In the year 1996, what is the difference between the Aid flow from UN agencies (US$) of Low & middle income and Aid flow from UN agencies (US$) of Middle East & North Africa (developing only)?
Your answer should be compact. 0. In the year 1996, what is the difference between the Aid flow from UN agencies (US$) of Middle East & North Africa (all income levels) and Aid flow from UN agencies (US$) of Middle East & North Africa (developing only)?
Provide a short and direct response. 0. In the year 1996, what is the difference between the Aid flow from UN agencies (US$) of Middle East & North Africa (developing only) and Aid flow from UN agencies (US$) of Middle income?
Ensure brevity in your answer.  0. In the year 1997, what is the difference between the Aid flow from UN agencies (US$) of Low & middle income and Aid flow from UN agencies (US$) of Middle East & North Africa (developing only)?
Keep it short and to the point. 0. In the year 1997, what is the difference between the Aid flow from UN agencies (US$) of Middle East & North Africa (all income levels) and Aid flow from UN agencies (US$) of Middle income?
Ensure brevity in your answer.  0. In the year 1997, what is the difference between the Aid flow from UN agencies (US$) of Middle East & North Africa (developing only) and Aid flow from UN agencies (US$) of Middle income?
Offer a very short reply. 0. In the year 1998, what is the difference between the Aid flow from UN agencies (US$) of Low & middle income and Aid flow from UN agencies (US$) of Middle East & North Africa (developing only)?
Your answer should be compact. 0. In the year 1998, what is the difference between the Aid flow from UN agencies (US$) of Low & middle income and Aid flow from UN agencies (US$) of Middle income?
Your answer should be compact. 0. What is the ratio of the Aid flow from UN agencies (US$) of Low & middle income in 1992 to that in 1993?
Offer a very short reply. 1.02. What is the ratio of the Aid flow from UN agencies (US$) in Middle East & North Africa (all income levels) in 1992 to that in 1993?
Provide a short and direct response. 1.02. What is the ratio of the Aid flow from UN agencies (US$) of Middle East & North Africa (developing only) in 1992 to that in 1993?
Offer a very short reply. 1.02. What is the ratio of the Aid flow from UN agencies (US$) in Middle income in 1992 to that in 1993?
Make the answer very short. 0.66. What is the ratio of the Aid flow from UN agencies (US$) of Low & middle income in 1992 to that in 1994?
Provide a succinct answer. 0.93. What is the ratio of the Aid flow from UN agencies (US$) in Middle East & North Africa (all income levels) in 1992 to that in 1994?
Keep it short and to the point. 0.93. What is the ratio of the Aid flow from UN agencies (US$) of Middle East & North Africa (developing only) in 1992 to that in 1994?
Ensure brevity in your answer.  0.93. What is the ratio of the Aid flow from UN agencies (US$) of Middle income in 1992 to that in 1994?
Your response must be concise. 0.44. What is the ratio of the Aid flow from UN agencies (US$) of Low & middle income in 1992 to that in 1995?
Your answer should be very brief. 0.88. What is the ratio of the Aid flow from UN agencies (US$) of Middle East & North Africa (all income levels) in 1992 to that in 1995?
Offer a very short reply. 0.88. What is the ratio of the Aid flow from UN agencies (US$) of Middle East & North Africa (developing only) in 1992 to that in 1995?
Your response must be concise. 0.88. What is the ratio of the Aid flow from UN agencies (US$) of Middle income in 1992 to that in 1995?
Your answer should be compact. 0.42. What is the ratio of the Aid flow from UN agencies (US$) in Low & middle income in 1992 to that in 1996?
Keep it short and to the point. 1.29. What is the ratio of the Aid flow from UN agencies (US$) of Middle East & North Africa (all income levels) in 1992 to that in 1996?
Provide a short and direct response. 1.29. What is the ratio of the Aid flow from UN agencies (US$) of Middle East & North Africa (developing only) in 1992 to that in 1996?
Keep it short and to the point. 1.29. What is the ratio of the Aid flow from UN agencies (US$) of Middle income in 1992 to that in 1996?
Your response must be concise. 0.57. What is the ratio of the Aid flow from UN agencies (US$) of Low & middle income in 1992 to that in 1997?
Keep it short and to the point. 1.16. What is the ratio of the Aid flow from UN agencies (US$) in Middle East & North Africa (all income levels) in 1992 to that in 1997?
Offer a terse response. 1.16. What is the ratio of the Aid flow from UN agencies (US$) of Middle East & North Africa (developing only) in 1992 to that in 1997?
Your answer should be very brief. 1.16. What is the ratio of the Aid flow from UN agencies (US$) in Middle income in 1992 to that in 1997?
Keep it short and to the point. 0.51. What is the ratio of the Aid flow from UN agencies (US$) of Low & middle income in 1992 to that in 1998?
Provide a short and direct response. 1.03. What is the ratio of the Aid flow from UN agencies (US$) of Middle East & North Africa (all income levels) in 1992 to that in 1998?
Make the answer very short. 1.03. What is the ratio of the Aid flow from UN agencies (US$) in Middle East & North Africa (developing only) in 1992 to that in 1998?
Provide a succinct answer. 1.03. What is the ratio of the Aid flow from UN agencies (US$) of Middle income in 1992 to that in 1998?
Offer a terse response. 0.46. What is the ratio of the Aid flow from UN agencies (US$) in Low & middle income in 1993 to that in 1994?
Your response must be concise. 0.91. What is the ratio of the Aid flow from UN agencies (US$) in Middle East & North Africa (all income levels) in 1993 to that in 1994?
Keep it short and to the point. 0.91. What is the ratio of the Aid flow from UN agencies (US$) in Middle East & North Africa (developing only) in 1993 to that in 1994?
Offer a terse response. 0.91. What is the ratio of the Aid flow from UN agencies (US$) in Middle income in 1993 to that in 1994?
Offer a very short reply. 0.67. What is the ratio of the Aid flow from UN agencies (US$) in Low & middle income in 1993 to that in 1995?
Keep it short and to the point. 0.86. What is the ratio of the Aid flow from UN agencies (US$) of Middle East & North Africa (all income levels) in 1993 to that in 1995?
Provide a short and direct response. 0.86. What is the ratio of the Aid flow from UN agencies (US$) of Middle East & North Africa (developing only) in 1993 to that in 1995?
Your response must be concise. 0.86. What is the ratio of the Aid flow from UN agencies (US$) of Middle income in 1993 to that in 1995?
Give a very brief answer. 0.63. What is the ratio of the Aid flow from UN agencies (US$) of Low & middle income in 1993 to that in 1996?
Offer a terse response. 1.26. What is the ratio of the Aid flow from UN agencies (US$) of Middle East & North Africa (all income levels) in 1993 to that in 1996?
Ensure brevity in your answer.  1.26. What is the ratio of the Aid flow from UN agencies (US$) in Middle East & North Africa (developing only) in 1993 to that in 1996?
Offer a terse response. 1.26. What is the ratio of the Aid flow from UN agencies (US$) in Middle income in 1993 to that in 1996?
Your answer should be compact. 0.87. What is the ratio of the Aid flow from UN agencies (US$) in Low & middle income in 1993 to that in 1997?
Your answer should be very brief. 1.14. What is the ratio of the Aid flow from UN agencies (US$) in Middle East & North Africa (all income levels) in 1993 to that in 1997?
Offer a terse response. 1.14. What is the ratio of the Aid flow from UN agencies (US$) of Middle East & North Africa (developing only) in 1993 to that in 1997?
Your answer should be compact. 1.14. What is the ratio of the Aid flow from UN agencies (US$) in Middle income in 1993 to that in 1997?
Give a very brief answer. 0.78. What is the ratio of the Aid flow from UN agencies (US$) in Low & middle income in 1993 to that in 1998?
Your answer should be compact. 1. What is the ratio of the Aid flow from UN agencies (US$) in Middle income in 1993 to that in 1998?
Ensure brevity in your answer.  0.69. What is the ratio of the Aid flow from UN agencies (US$) in Low & middle income in 1994 to that in 1995?
Keep it short and to the point. 0.94. What is the ratio of the Aid flow from UN agencies (US$) in Middle East & North Africa (all income levels) in 1994 to that in 1995?
Your response must be concise. 0.94. What is the ratio of the Aid flow from UN agencies (US$) of Middle East & North Africa (developing only) in 1994 to that in 1995?
Ensure brevity in your answer.  0.94. What is the ratio of the Aid flow from UN agencies (US$) of Middle income in 1994 to that in 1995?
Your answer should be very brief. 0.95. What is the ratio of the Aid flow from UN agencies (US$) of Low & middle income in 1994 to that in 1996?
Your answer should be very brief. 1.39. What is the ratio of the Aid flow from UN agencies (US$) of Middle East & North Africa (all income levels) in 1994 to that in 1996?
Your answer should be compact. 1.39. What is the ratio of the Aid flow from UN agencies (US$) in Middle East & North Africa (developing only) in 1994 to that in 1996?
Keep it short and to the point. 1.39. What is the ratio of the Aid flow from UN agencies (US$) of Middle income in 1994 to that in 1996?
Make the answer very short. 1.3. What is the ratio of the Aid flow from UN agencies (US$) of Low & middle income in 1994 to that in 1997?
Your answer should be compact. 1.25. What is the ratio of the Aid flow from UN agencies (US$) in Middle East & North Africa (all income levels) in 1994 to that in 1997?
Provide a succinct answer. 1.25. What is the ratio of the Aid flow from UN agencies (US$) of Middle East & North Africa (developing only) in 1994 to that in 1997?
Make the answer very short. 1.25. What is the ratio of the Aid flow from UN agencies (US$) of Middle income in 1994 to that in 1997?
Your answer should be very brief. 1.17. What is the ratio of the Aid flow from UN agencies (US$) in Low & middle income in 1994 to that in 1998?
Offer a very short reply. 1.1. What is the ratio of the Aid flow from UN agencies (US$) of Middle East & North Africa (all income levels) in 1994 to that in 1998?
Give a very brief answer. 1.1. What is the ratio of the Aid flow from UN agencies (US$) of Middle East & North Africa (developing only) in 1994 to that in 1998?
Provide a succinct answer. 1.1. What is the ratio of the Aid flow from UN agencies (US$) in Middle income in 1994 to that in 1998?
Your answer should be compact. 1.03. What is the ratio of the Aid flow from UN agencies (US$) of Low & middle income in 1995 to that in 1996?
Your answer should be very brief. 1.47. What is the ratio of the Aid flow from UN agencies (US$) in Middle East & North Africa (all income levels) in 1995 to that in 1996?
Ensure brevity in your answer.  1.47. What is the ratio of the Aid flow from UN agencies (US$) of Middle East & North Africa (developing only) in 1995 to that in 1996?
Make the answer very short. 1.47. What is the ratio of the Aid flow from UN agencies (US$) in Middle income in 1995 to that in 1996?
Make the answer very short. 1.38. What is the ratio of the Aid flow from UN agencies (US$) in Low & middle income in 1995 to that in 1997?
Keep it short and to the point. 1.32. What is the ratio of the Aid flow from UN agencies (US$) of Middle East & North Africa (all income levels) in 1995 to that in 1997?
Offer a terse response. 1.32. What is the ratio of the Aid flow from UN agencies (US$) in Middle East & North Africa (developing only) in 1995 to that in 1997?
Provide a short and direct response. 1.32. What is the ratio of the Aid flow from UN agencies (US$) in Middle income in 1995 to that in 1997?
Offer a very short reply. 1.24. What is the ratio of the Aid flow from UN agencies (US$) in Low & middle income in 1995 to that in 1998?
Give a very brief answer. 1.17. What is the ratio of the Aid flow from UN agencies (US$) in Middle East & North Africa (all income levels) in 1995 to that in 1998?
Make the answer very short. 1.17. What is the ratio of the Aid flow from UN agencies (US$) of Middle East & North Africa (developing only) in 1995 to that in 1998?
Provide a succinct answer. 1.17. What is the ratio of the Aid flow from UN agencies (US$) of Middle income in 1995 to that in 1998?
Offer a very short reply. 1.09. What is the ratio of the Aid flow from UN agencies (US$) in Low & middle income in 1996 to that in 1997?
Provide a succinct answer. 0.9. What is the ratio of the Aid flow from UN agencies (US$) of Middle East & North Africa (all income levels) in 1996 to that in 1997?
Ensure brevity in your answer.  0.9. What is the ratio of the Aid flow from UN agencies (US$) in Middle East & North Africa (developing only) in 1996 to that in 1997?
Offer a very short reply. 0.9. What is the ratio of the Aid flow from UN agencies (US$) in Middle income in 1996 to that in 1997?
Your answer should be compact. 0.9. What is the ratio of the Aid flow from UN agencies (US$) in Low & middle income in 1996 to that in 1998?
Ensure brevity in your answer.  0.79. What is the ratio of the Aid flow from UN agencies (US$) in Middle East & North Africa (all income levels) in 1996 to that in 1998?
Offer a very short reply. 0.79. What is the ratio of the Aid flow from UN agencies (US$) of Middle East & North Africa (developing only) in 1996 to that in 1998?
Ensure brevity in your answer.  0.79. What is the ratio of the Aid flow from UN agencies (US$) of Middle income in 1996 to that in 1998?
Offer a terse response. 0.79. What is the ratio of the Aid flow from UN agencies (US$) of Low & middle income in 1997 to that in 1998?
Provide a succinct answer. 0.88. What is the ratio of the Aid flow from UN agencies (US$) in Middle East & North Africa (all income levels) in 1997 to that in 1998?
Your answer should be very brief. 0.88. What is the ratio of the Aid flow from UN agencies (US$) in Middle East & North Africa (developing only) in 1997 to that in 1998?
Ensure brevity in your answer.  0.88. What is the ratio of the Aid flow from UN agencies (US$) of Middle income in 1997 to that in 1998?
Your answer should be compact. 0.88. What is the difference between the highest and the second highest Aid flow from UN agencies (US$) in Low & middle income?
Your answer should be compact. 1.92e+07. What is the difference between the highest and the second highest Aid flow from UN agencies (US$) of Middle East & North Africa (all income levels)?
Give a very brief answer. 1.92e+07. What is the difference between the highest and the second highest Aid flow from UN agencies (US$) in Middle East & North Africa (developing only)?
Your answer should be very brief. 1.92e+07. What is the difference between the highest and the second highest Aid flow from UN agencies (US$) of Middle income?
Your answer should be very brief. 1.79e+07. What is the difference between the highest and the lowest Aid flow from UN agencies (US$) of Low & middle income?
Provide a succinct answer. 1.12e+08. What is the difference between the highest and the lowest Aid flow from UN agencies (US$) of Middle East & North Africa (all income levels)?
Ensure brevity in your answer.  1.12e+08. What is the difference between the highest and the lowest Aid flow from UN agencies (US$) of Middle East & North Africa (developing only)?
Your answer should be very brief. 1.12e+08. What is the difference between the highest and the lowest Aid flow from UN agencies (US$) in Middle income?
Make the answer very short. 1.90e+08. 